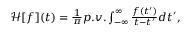<formula> <loc_0><loc_0><loc_500><loc_500>\begin{array} { r } { \mathcal { H } [ f ] ( t ) = \frac { 1 } { \pi } p . v . \int _ { - \infty } ^ { \infty } \frac { f ( t ^ { \prime } ) } { t - t ^ { \prime } } d t ^ { \prime } , } \end{array}</formula> 